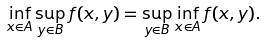Convert formula to latex. <formula><loc_0><loc_0><loc_500><loc_500>\inf _ { x \in A } \sup _ { y \in B } f ( x , y ) = \sup _ { y \in B } \inf _ { x \in A } f ( x , y ) .</formula> 